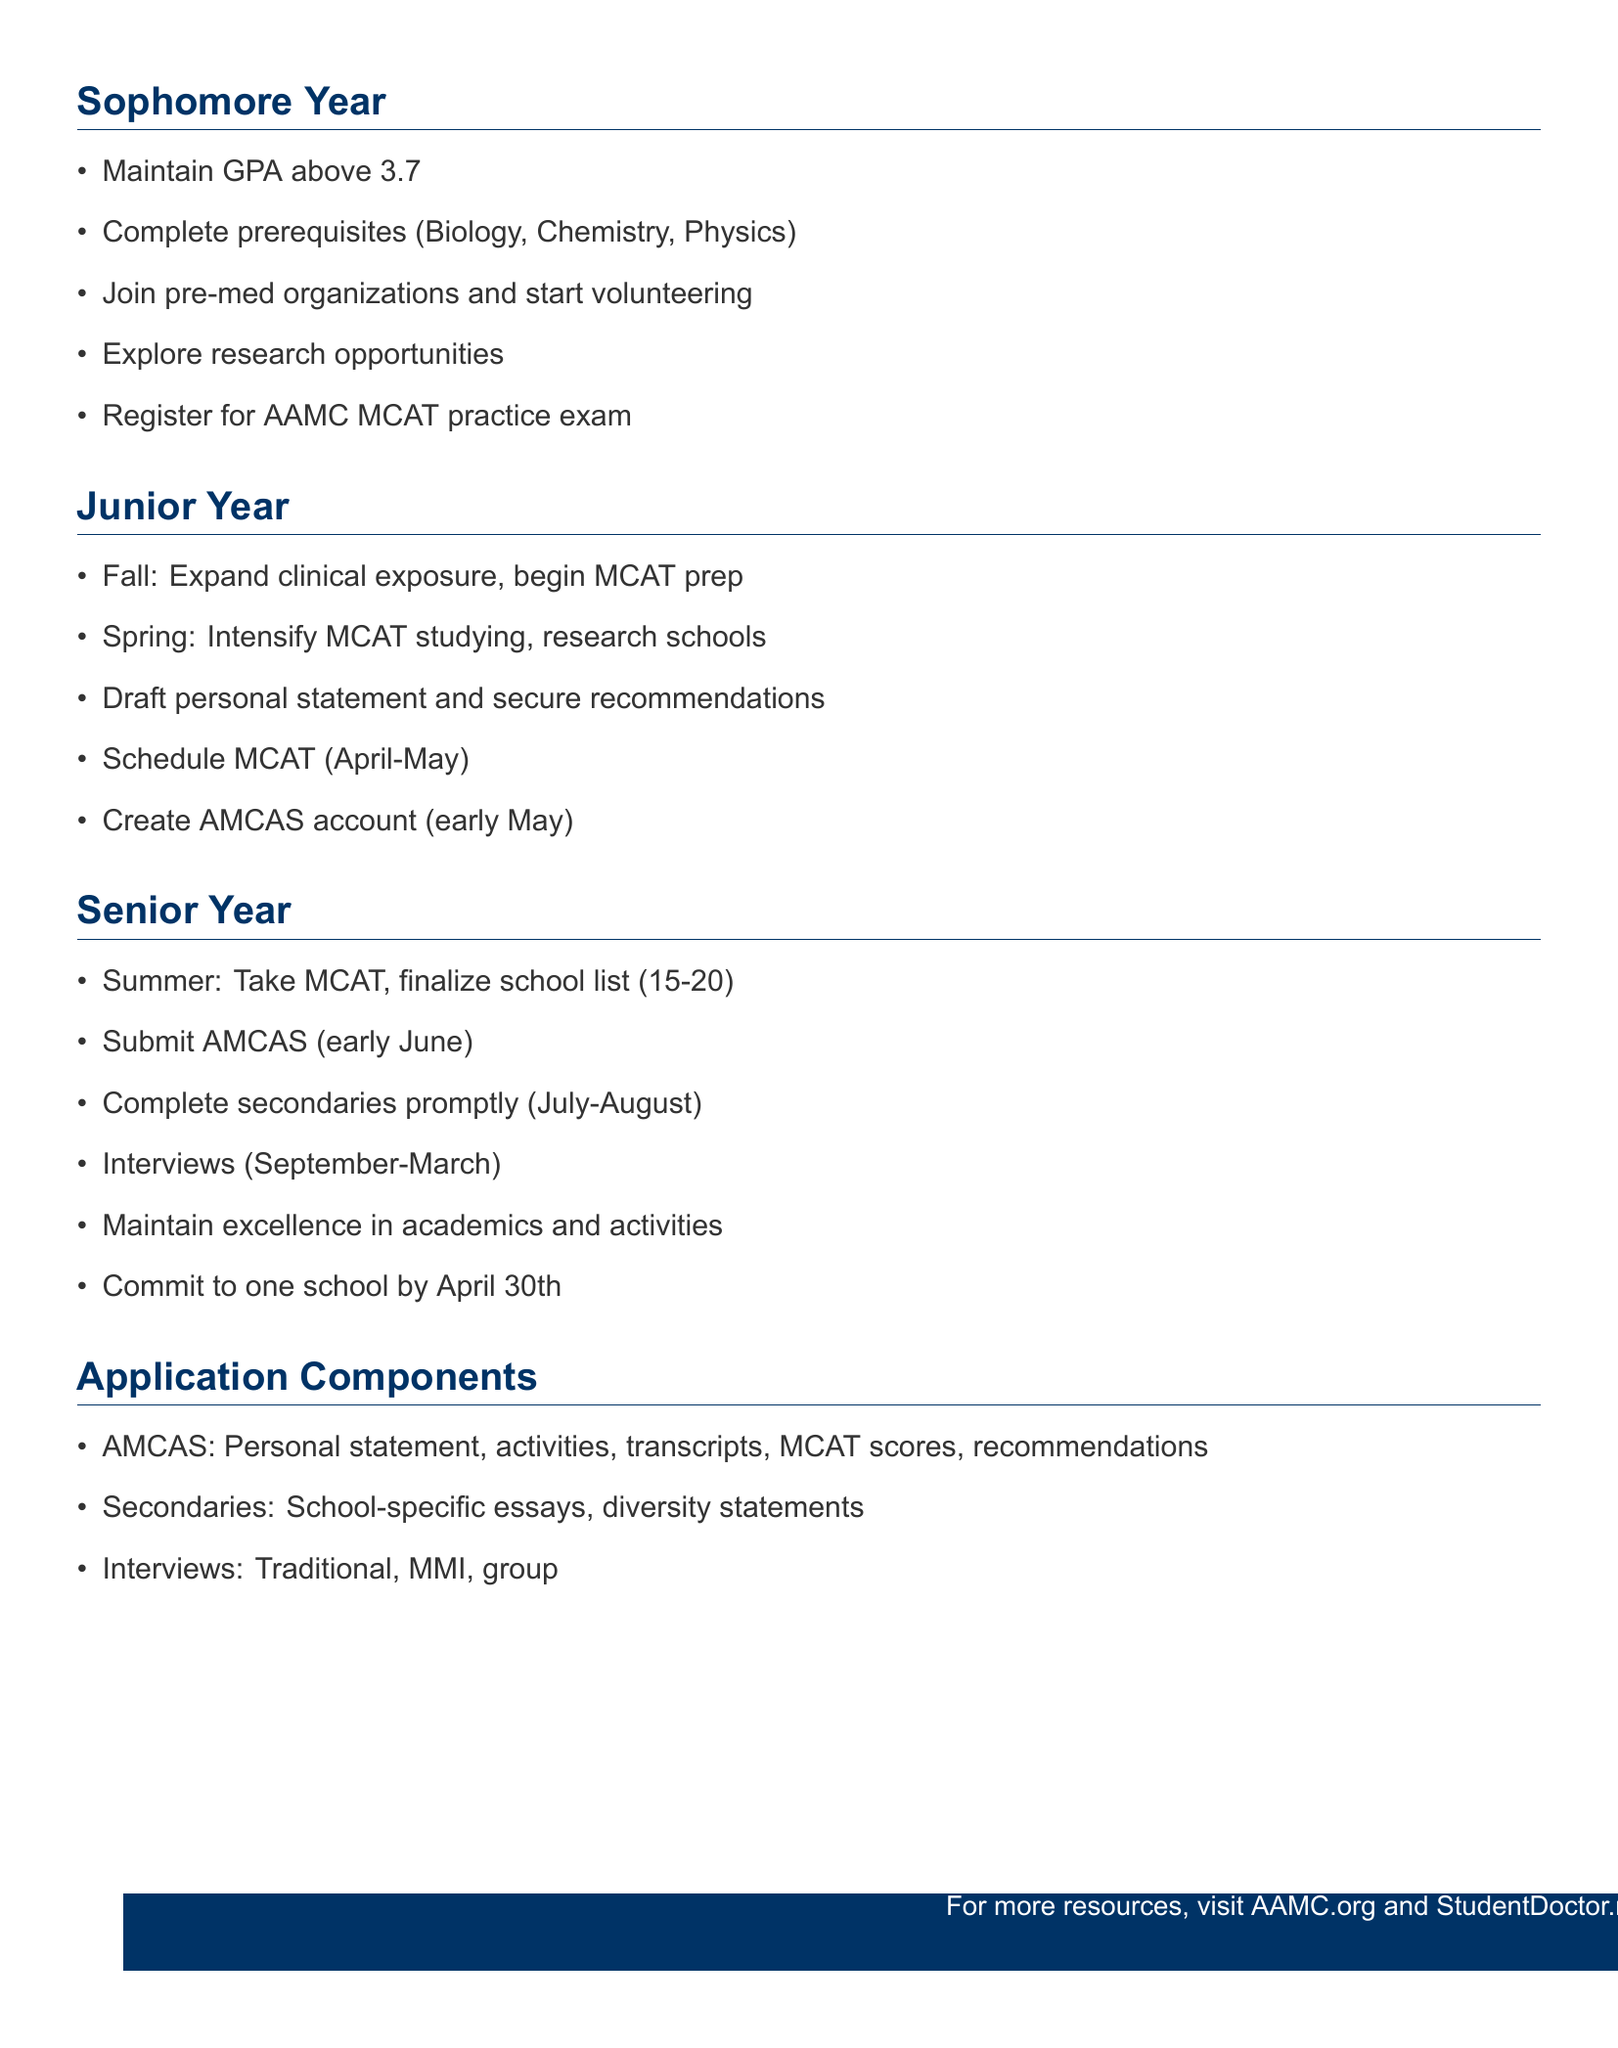What is the recommended GPA aim for sophomore year? The document states that students should aim for a GPA of 3.7 or higher during their sophomore year.
Answer: 3.7+ What key milestone occurs in early June of senior year? The document highlights the submission of the AMCAS application as a key milestone in early June of senior year.
Answer: AMCAS application submission In which semester of junior year should students begin MCAT preparation? The timeline specifies that MCAT preparation should begin in the fall semester of junior year.
Answer: Fall semester What is the maximum character count for the personal statement in the AMCAS application? The document specifies that the personal statement has a maximum character limit of 5300 characters.
Answer: 5300 characters How many medical schools are recommended for the school list during the summer before senior year? The outline recommends finalizing a school list that includes 15 to 20 schools in the summer before senior year.
Answer: 15-20 schools What type of interviews are included in the application components? The document lists traditional one-on-one interviews, multiple mini interviews, and group interviews as included types.
Answer: Traditional, MMI, group When do medical school interviews typically occur according to the timeline? Interviews are indicated to occur from September to March.
Answer: September to March What action should students take promptly after receiving their secondary applications? The document advises students to submit secondary applications within two weeks of receipt.
Answer: Submit within 2 weeks 